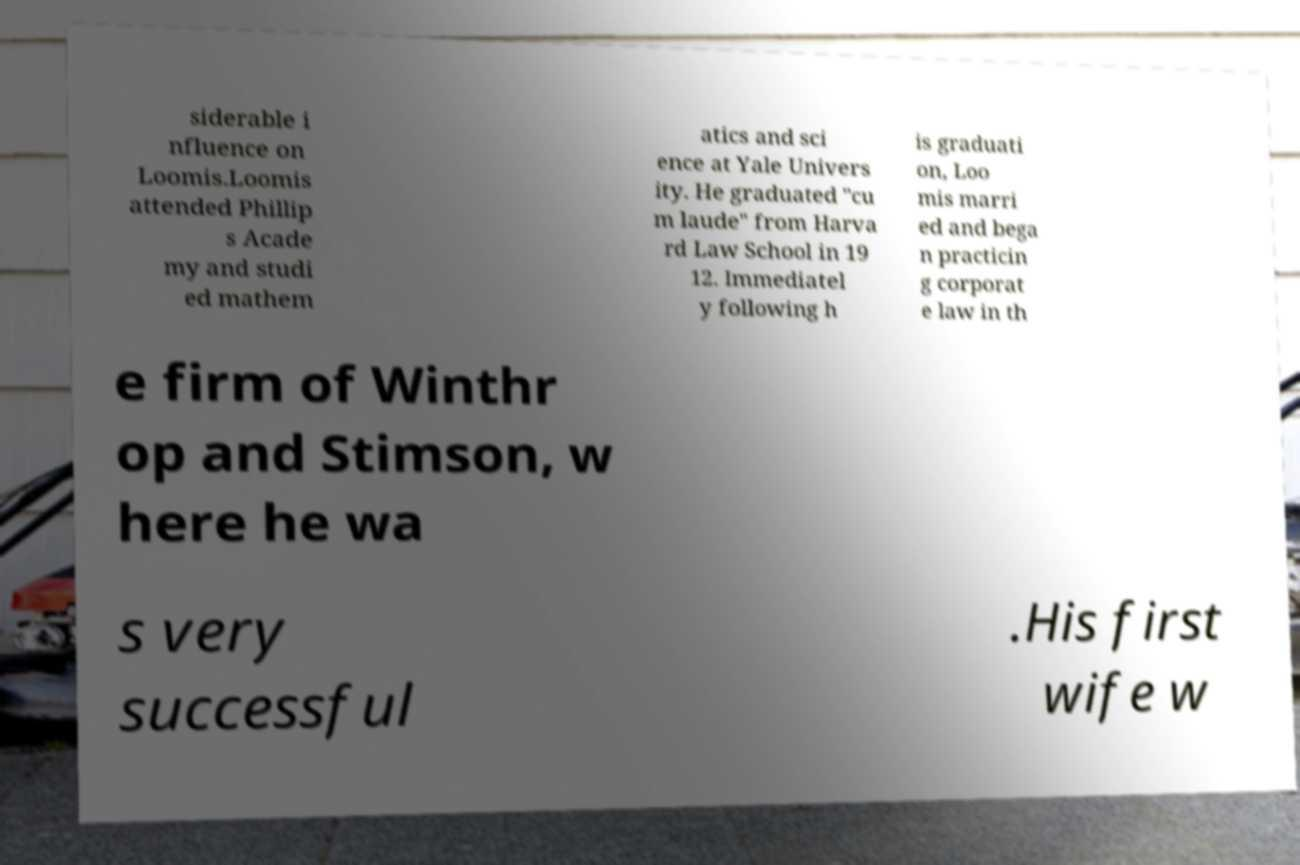For documentation purposes, I need the text within this image transcribed. Could you provide that? siderable i nfluence on Loomis.Loomis attended Phillip s Acade my and studi ed mathem atics and sci ence at Yale Univers ity. He graduated "cu m laude" from Harva rd Law School in 19 12. Immediatel y following h is graduati on, Loo mis marri ed and bega n practicin g corporat e law in th e firm of Winthr op and Stimson, w here he wa s very successful .His first wife w 